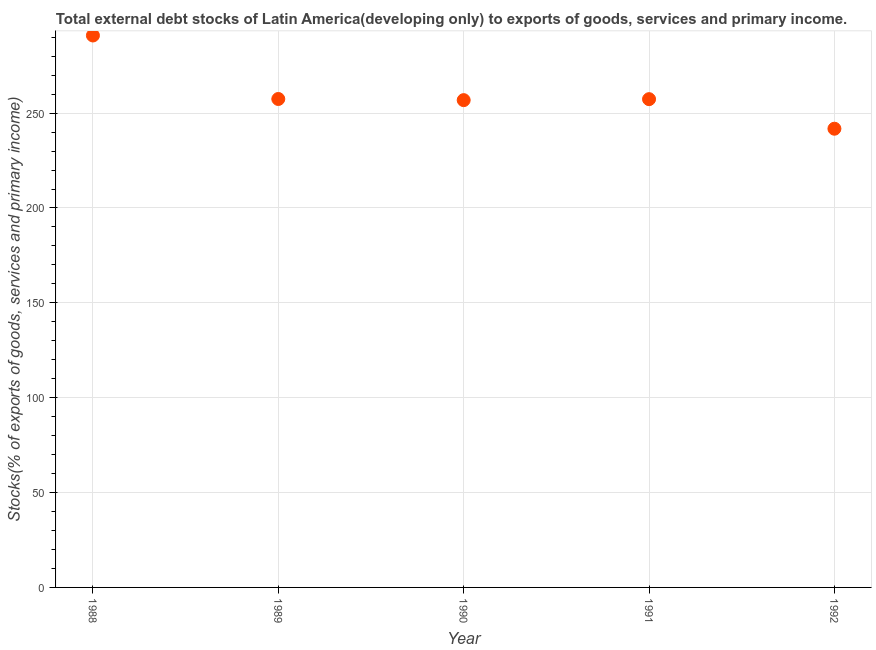What is the external debt stocks in 1989?
Ensure brevity in your answer.  257.46. Across all years, what is the maximum external debt stocks?
Your answer should be compact. 290.93. Across all years, what is the minimum external debt stocks?
Offer a very short reply. 241.79. In which year was the external debt stocks maximum?
Provide a short and direct response. 1988. What is the sum of the external debt stocks?
Give a very brief answer. 1304.4. What is the difference between the external debt stocks in 1988 and 1991?
Your response must be concise. 33.56. What is the average external debt stocks per year?
Ensure brevity in your answer.  260.88. What is the median external debt stocks?
Offer a terse response. 257.37. Do a majority of the years between 1990 and 1989 (inclusive) have external debt stocks greater than 10 %?
Keep it short and to the point. No. What is the ratio of the external debt stocks in 1988 to that in 1991?
Ensure brevity in your answer.  1.13. Is the external debt stocks in 1990 less than that in 1992?
Offer a terse response. No. What is the difference between the highest and the second highest external debt stocks?
Your answer should be very brief. 33.47. Is the sum of the external debt stocks in 1990 and 1991 greater than the maximum external debt stocks across all years?
Ensure brevity in your answer.  Yes. What is the difference between the highest and the lowest external debt stocks?
Make the answer very short. 49.14. In how many years, is the external debt stocks greater than the average external debt stocks taken over all years?
Provide a short and direct response. 1. What is the difference between two consecutive major ticks on the Y-axis?
Your response must be concise. 50. Are the values on the major ticks of Y-axis written in scientific E-notation?
Your answer should be very brief. No. What is the title of the graph?
Your answer should be compact. Total external debt stocks of Latin America(developing only) to exports of goods, services and primary income. What is the label or title of the X-axis?
Provide a short and direct response. Year. What is the label or title of the Y-axis?
Your response must be concise. Stocks(% of exports of goods, services and primary income). What is the Stocks(% of exports of goods, services and primary income) in 1988?
Offer a terse response. 290.93. What is the Stocks(% of exports of goods, services and primary income) in 1989?
Your answer should be very brief. 257.46. What is the Stocks(% of exports of goods, services and primary income) in 1990?
Your answer should be compact. 256.85. What is the Stocks(% of exports of goods, services and primary income) in 1991?
Keep it short and to the point. 257.37. What is the Stocks(% of exports of goods, services and primary income) in 1992?
Your answer should be very brief. 241.79. What is the difference between the Stocks(% of exports of goods, services and primary income) in 1988 and 1989?
Provide a succinct answer. 33.47. What is the difference between the Stocks(% of exports of goods, services and primary income) in 1988 and 1990?
Offer a terse response. 34.08. What is the difference between the Stocks(% of exports of goods, services and primary income) in 1988 and 1991?
Give a very brief answer. 33.56. What is the difference between the Stocks(% of exports of goods, services and primary income) in 1988 and 1992?
Provide a succinct answer. 49.14. What is the difference between the Stocks(% of exports of goods, services and primary income) in 1989 and 1990?
Your answer should be very brief. 0.6. What is the difference between the Stocks(% of exports of goods, services and primary income) in 1989 and 1991?
Your answer should be very brief. 0.09. What is the difference between the Stocks(% of exports of goods, services and primary income) in 1989 and 1992?
Your answer should be compact. 15.67. What is the difference between the Stocks(% of exports of goods, services and primary income) in 1990 and 1991?
Give a very brief answer. -0.51. What is the difference between the Stocks(% of exports of goods, services and primary income) in 1990 and 1992?
Your response must be concise. 15.06. What is the difference between the Stocks(% of exports of goods, services and primary income) in 1991 and 1992?
Ensure brevity in your answer.  15.58. What is the ratio of the Stocks(% of exports of goods, services and primary income) in 1988 to that in 1989?
Offer a terse response. 1.13. What is the ratio of the Stocks(% of exports of goods, services and primary income) in 1988 to that in 1990?
Make the answer very short. 1.13. What is the ratio of the Stocks(% of exports of goods, services and primary income) in 1988 to that in 1991?
Keep it short and to the point. 1.13. What is the ratio of the Stocks(% of exports of goods, services and primary income) in 1988 to that in 1992?
Provide a succinct answer. 1.2. What is the ratio of the Stocks(% of exports of goods, services and primary income) in 1989 to that in 1990?
Ensure brevity in your answer.  1. What is the ratio of the Stocks(% of exports of goods, services and primary income) in 1989 to that in 1992?
Make the answer very short. 1.06. What is the ratio of the Stocks(% of exports of goods, services and primary income) in 1990 to that in 1991?
Give a very brief answer. 1. What is the ratio of the Stocks(% of exports of goods, services and primary income) in 1990 to that in 1992?
Make the answer very short. 1.06. What is the ratio of the Stocks(% of exports of goods, services and primary income) in 1991 to that in 1992?
Ensure brevity in your answer.  1.06. 